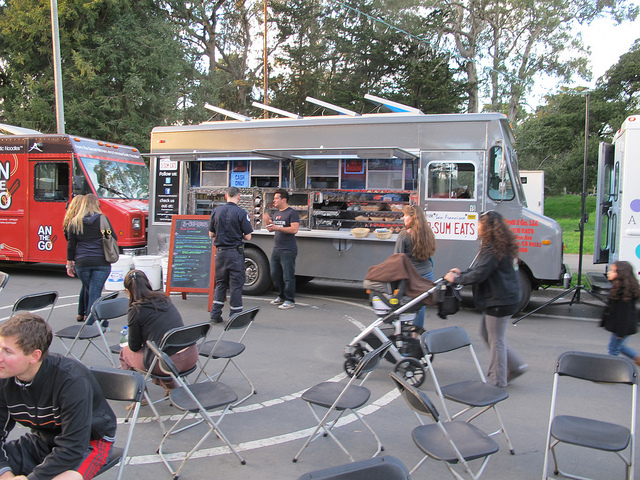Are there any details that suggest the time of day in the image? The shadows are long and the lighting is soft, indicating that the photo was likely taken in the evening during the 'golden hour' just before sunset. This time of day often brings people out to enjoy meals and the cooler temperature after a day's work. 